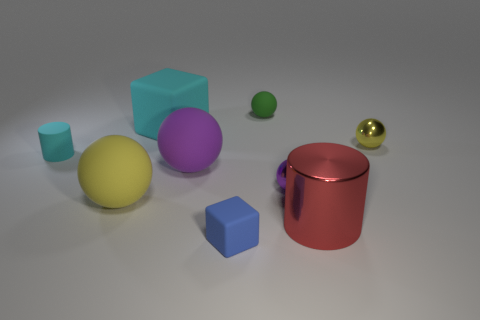Subtract all small green rubber balls. How many balls are left? 4 Subtract all yellow balls. How many balls are left? 3 Subtract all cyan spheres. Subtract all green cubes. How many spheres are left? 5 Subtract all blocks. How many objects are left? 7 Add 7 small matte spheres. How many small matte spheres exist? 8 Subtract 0 blue cylinders. How many objects are left? 9 Subtract all purple matte balls. Subtract all tiny yellow balls. How many objects are left? 7 Add 5 small purple metal spheres. How many small purple metal spheres are left? 6 